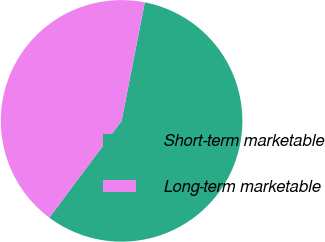Convert chart to OTSL. <chart><loc_0><loc_0><loc_500><loc_500><pie_chart><fcel>Short-term marketable<fcel>Long-term marketable<nl><fcel>57.13%<fcel>42.87%<nl></chart> 